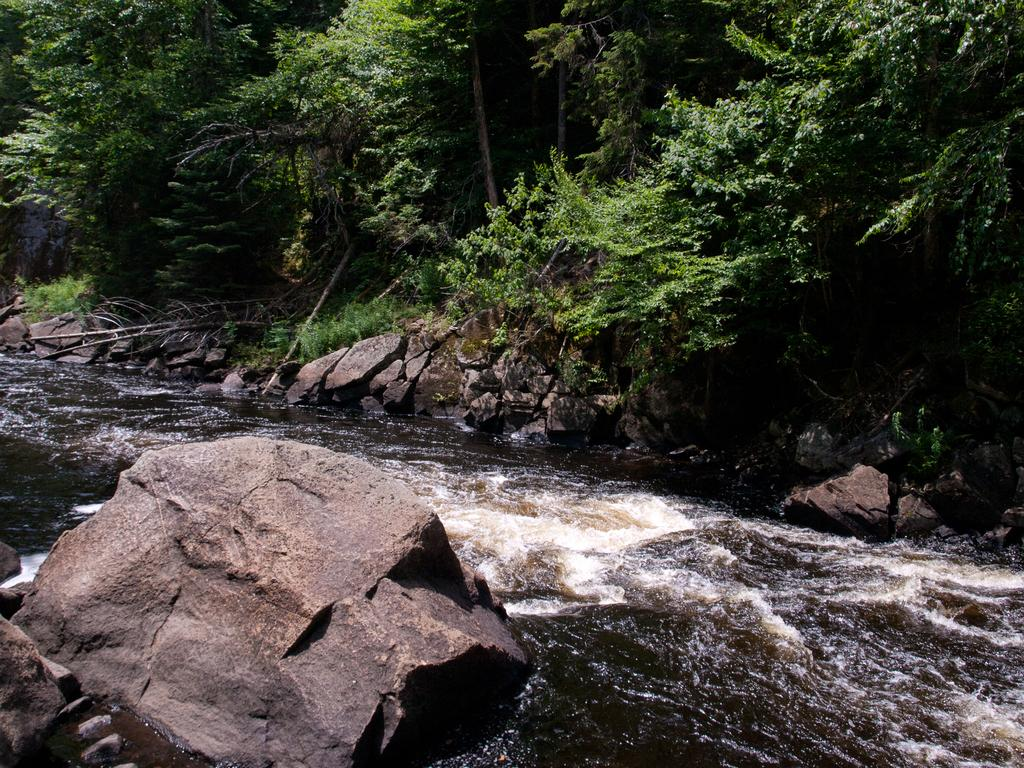What is the primary element visible in the image? There is water in the image. What other objects can be seen in the image? There are rocks in the image. What can be seen in the background of the image? There are trees in the background of the image. What type of shop can be seen in the image? There is no shop present in the image. Can you recite a verse that is written on the rocks in the image? There are no verses written on the rocks in the image. 